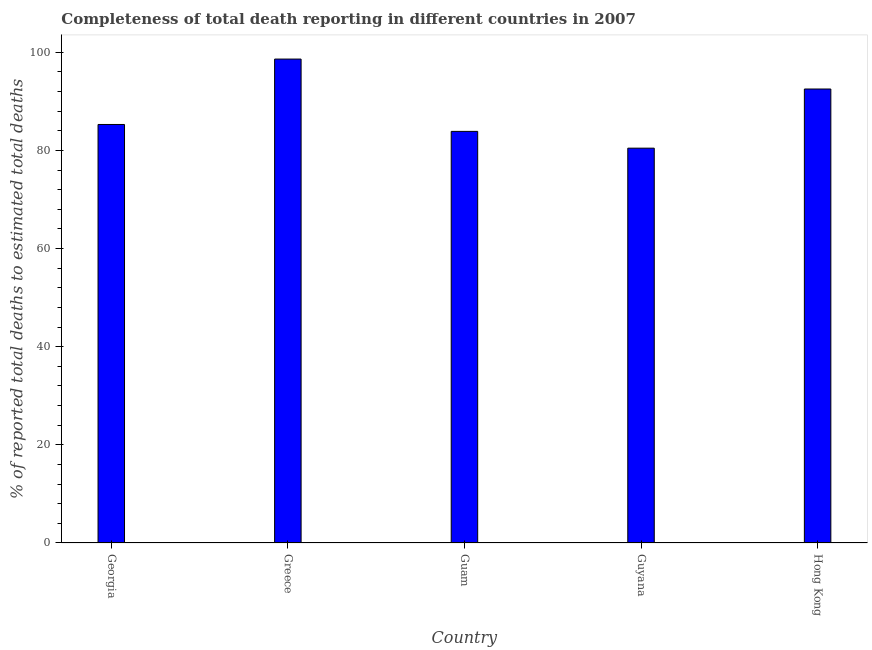Does the graph contain any zero values?
Make the answer very short. No. Does the graph contain grids?
Ensure brevity in your answer.  No. What is the title of the graph?
Offer a terse response. Completeness of total death reporting in different countries in 2007. What is the label or title of the X-axis?
Offer a terse response. Country. What is the label or title of the Y-axis?
Your response must be concise. % of reported total deaths to estimated total deaths. What is the completeness of total death reports in Guam?
Your answer should be very brief. 83.88. Across all countries, what is the maximum completeness of total death reports?
Offer a very short reply. 98.62. Across all countries, what is the minimum completeness of total death reports?
Keep it short and to the point. 80.46. In which country was the completeness of total death reports minimum?
Keep it short and to the point. Guyana. What is the sum of the completeness of total death reports?
Your answer should be very brief. 440.78. What is the difference between the completeness of total death reports in Guam and Guyana?
Provide a short and direct response. 3.42. What is the average completeness of total death reports per country?
Your answer should be very brief. 88.16. What is the median completeness of total death reports?
Give a very brief answer. 85.29. What is the ratio of the completeness of total death reports in Guyana to that in Hong Kong?
Keep it short and to the point. 0.87. Is the completeness of total death reports in Greece less than that in Hong Kong?
Provide a succinct answer. No. Is the difference between the completeness of total death reports in Georgia and Greece greater than the difference between any two countries?
Make the answer very short. No. What is the difference between the highest and the second highest completeness of total death reports?
Ensure brevity in your answer.  6.1. Is the sum of the completeness of total death reports in Guam and Hong Kong greater than the maximum completeness of total death reports across all countries?
Your answer should be very brief. Yes. What is the difference between the highest and the lowest completeness of total death reports?
Keep it short and to the point. 18.16. How many bars are there?
Provide a succinct answer. 5. How many countries are there in the graph?
Give a very brief answer. 5. Are the values on the major ticks of Y-axis written in scientific E-notation?
Ensure brevity in your answer.  No. What is the % of reported total deaths to estimated total deaths in Georgia?
Your answer should be very brief. 85.29. What is the % of reported total deaths to estimated total deaths in Greece?
Provide a succinct answer. 98.62. What is the % of reported total deaths to estimated total deaths of Guam?
Offer a terse response. 83.88. What is the % of reported total deaths to estimated total deaths of Guyana?
Give a very brief answer. 80.46. What is the % of reported total deaths to estimated total deaths of Hong Kong?
Your response must be concise. 92.52. What is the difference between the % of reported total deaths to estimated total deaths in Georgia and Greece?
Ensure brevity in your answer.  -13.33. What is the difference between the % of reported total deaths to estimated total deaths in Georgia and Guam?
Give a very brief answer. 1.41. What is the difference between the % of reported total deaths to estimated total deaths in Georgia and Guyana?
Offer a terse response. 4.83. What is the difference between the % of reported total deaths to estimated total deaths in Georgia and Hong Kong?
Offer a very short reply. -7.23. What is the difference between the % of reported total deaths to estimated total deaths in Greece and Guam?
Keep it short and to the point. 14.74. What is the difference between the % of reported total deaths to estimated total deaths in Greece and Guyana?
Your answer should be very brief. 18.16. What is the difference between the % of reported total deaths to estimated total deaths in Greece and Hong Kong?
Make the answer very short. 6.1. What is the difference between the % of reported total deaths to estimated total deaths in Guam and Guyana?
Give a very brief answer. 3.42. What is the difference between the % of reported total deaths to estimated total deaths in Guam and Hong Kong?
Make the answer very short. -8.63. What is the difference between the % of reported total deaths to estimated total deaths in Guyana and Hong Kong?
Your response must be concise. -12.05. What is the ratio of the % of reported total deaths to estimated total deaths in Georgia to that in Greece?
Your answer should be compact. 0.86. What is the ratio of the % of reported total deaths to estimated total deaths in Georgia to that in Guyana?
Provide a succinct answer. 1.06. What is the ratio of the % of reported total deaths to estimated total deaths in Georgia to that in Hong Kong?
Ensure brevity in your answer.  0.92. What is the ratio of the % of reported total deaths to estimated total deaths in Greece to that in Guam?
Your answer should be very brief. 1.18. What is the ratio of the % of reported total deaths to estimated total deaths in Greece to that in Guyana?
Your answer should be very brief. 1.23. What is the ratio of the % of reported total deaths to estimated total deaths in Greece to that in Hong Kong?
Give a very brief answer. 1.07. What is the ratio of the % of reported total deaths to estimated total deaths in Guam to that in Guyana?
Provide a short and direct response. 1.04. What is the ratio of the % of reported total deaths to estimated total deaths in Guam to that in Hong Kong?
Ensure brevity in your answer.  0.91. What is the ratio of the % of reported total deaths to estimated total deaths in Guyana to that in Hong Kong?
Provide a short and direct response. 0.87. 